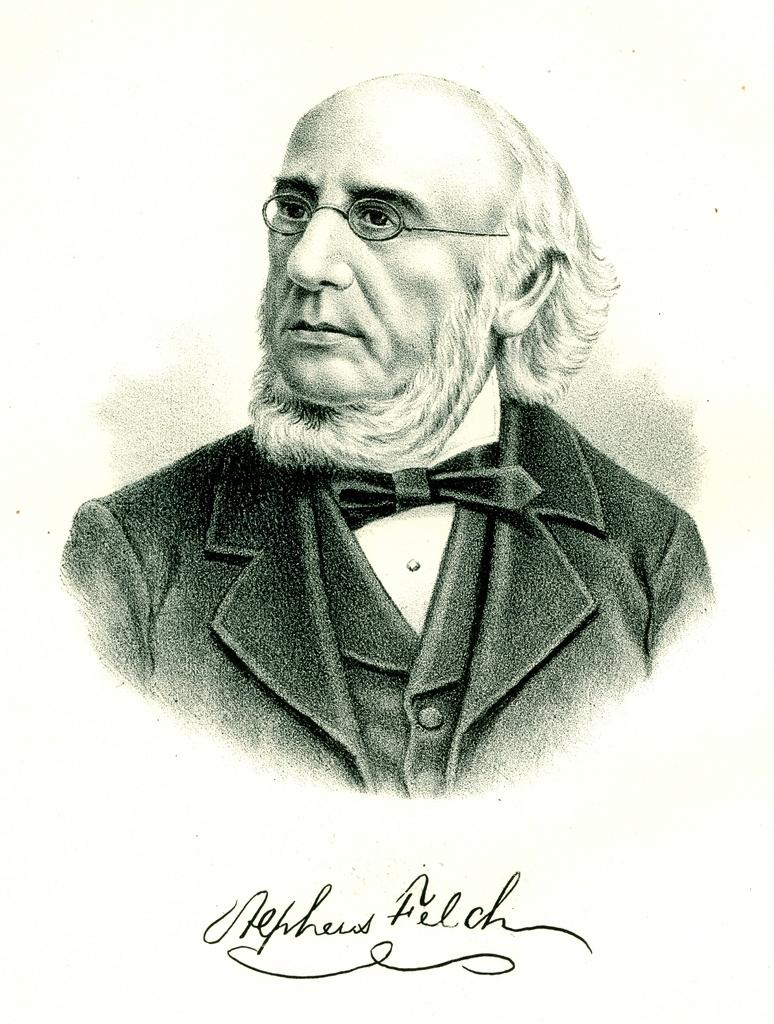What is the main subject of the image? There is a person in the image. Can you describe the person's appearance? The person is wearing spectacles, a tie, and a suit. What is the purpose of the white surface in the image? There is some text visible on a white surface. What type of art can be seen on the boy's shirt in the image? There is no boy present in the image, and no art can be seen on any shirt. How does the rock contribute to the overall composition of the image? There is no rock present in the image, so it cannot contribute to the composition. 